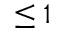Convert formula to latex. <formula><loc_0><loc_0><loc_500><loc_500>\leq 1</formula> 